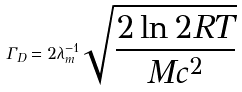<formula> <loc_0><loc_0><loc_500><loc_500>\Gamma _ { D } = 2 \lambda _ { m } ^ { - 1 } \sqrt { \frac { 2 \ln 2 R T } { M c ^ { 2 } } }</formula> 